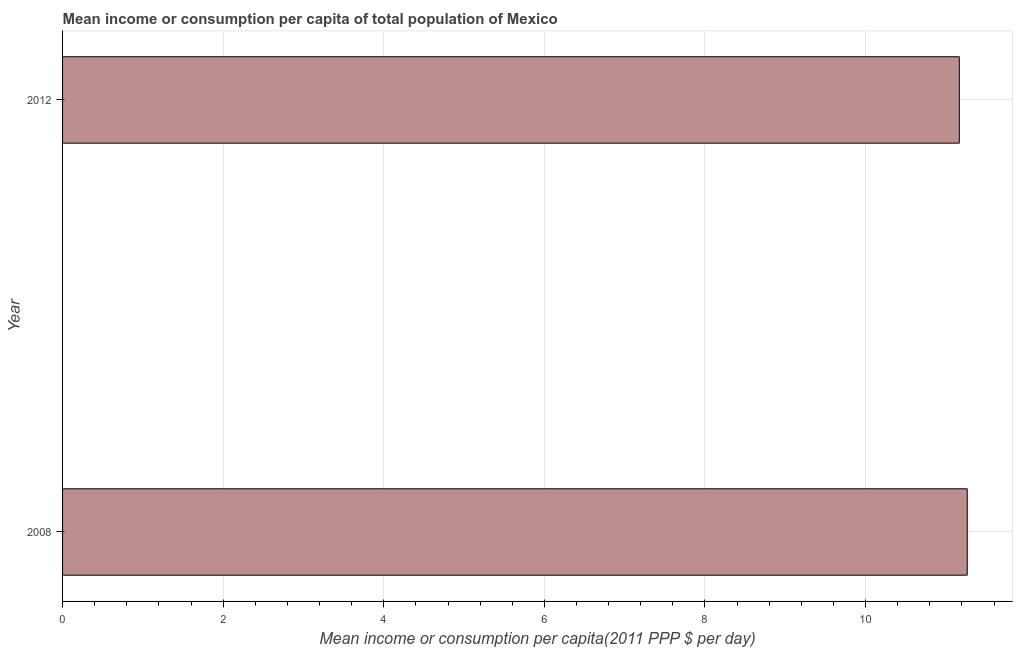What is the title of the graph?
Provide a succinct answer. Mean income or consumption per capita of total population of Mexico. What is the label or title of the X-axis?
Offer a very short reply. Mean income or consumption per capita(2011 PPP $ per day). What is the label or title of the Y-axis?
Make the answer very short. Year. What is the mean income or consumption in 2012?
Your answer should be very brief. 11.17. Across all years, what is the maximum mean income or consumption?
Make the answer very short. 11.27. Across all years, what is the minimum mean income or consumption?
Offer a terse response. 11.17. In which year was the mean income or consumption minimum?
Offer a very short reply. 2012. What is the sum of the mean income or consumption?
Provide a succinct answer. 22.43. What is the difference between the mean income or consumption in 2008 and 2012?
Keep it short and to the point. 0.1. What is the average mean income or consumption per year?
Ensure brevity in your answer.  11.22. What is the median mean income or consumption?
Your answer should be compact. 11.22. Do a majority of the years between 2008 and 2012 (inclusive) have mean income or consumption greater than 6.8 $?
Keep it short and to the point. Yes. What is the ratio of the mean income or consumption in 2008 to that in 2012?
Keep it short and to the point. 1.01. Is the mean income or consumption in 2008 less than that in 2012?
Give a very brief answer. No. In how many years, is the mean income or consumption greater than the average mean income or consumption taken over all years?
Give a very brief answer. 1. Are all the bars in the graph horizontal?
Ensure brevity in your answer.  Yes. Are the values on the major ticks of X-axis written in scientific E-notation?
Provide a short and direct response. No. What is the Mean income or consumption per capita(2011 PPP $ per day) of 2008?
Provide a succinct answer. 11.27. What is the Mean income or consumption per capita(2011 PPP $ per day) in 2012?
Your answer should be very brief. 11.17. What is the difference between the Mean income or consumption per capita(2011 PPP $ per day) in 2008 and 2012?
Make the answer very short. 0.1. 